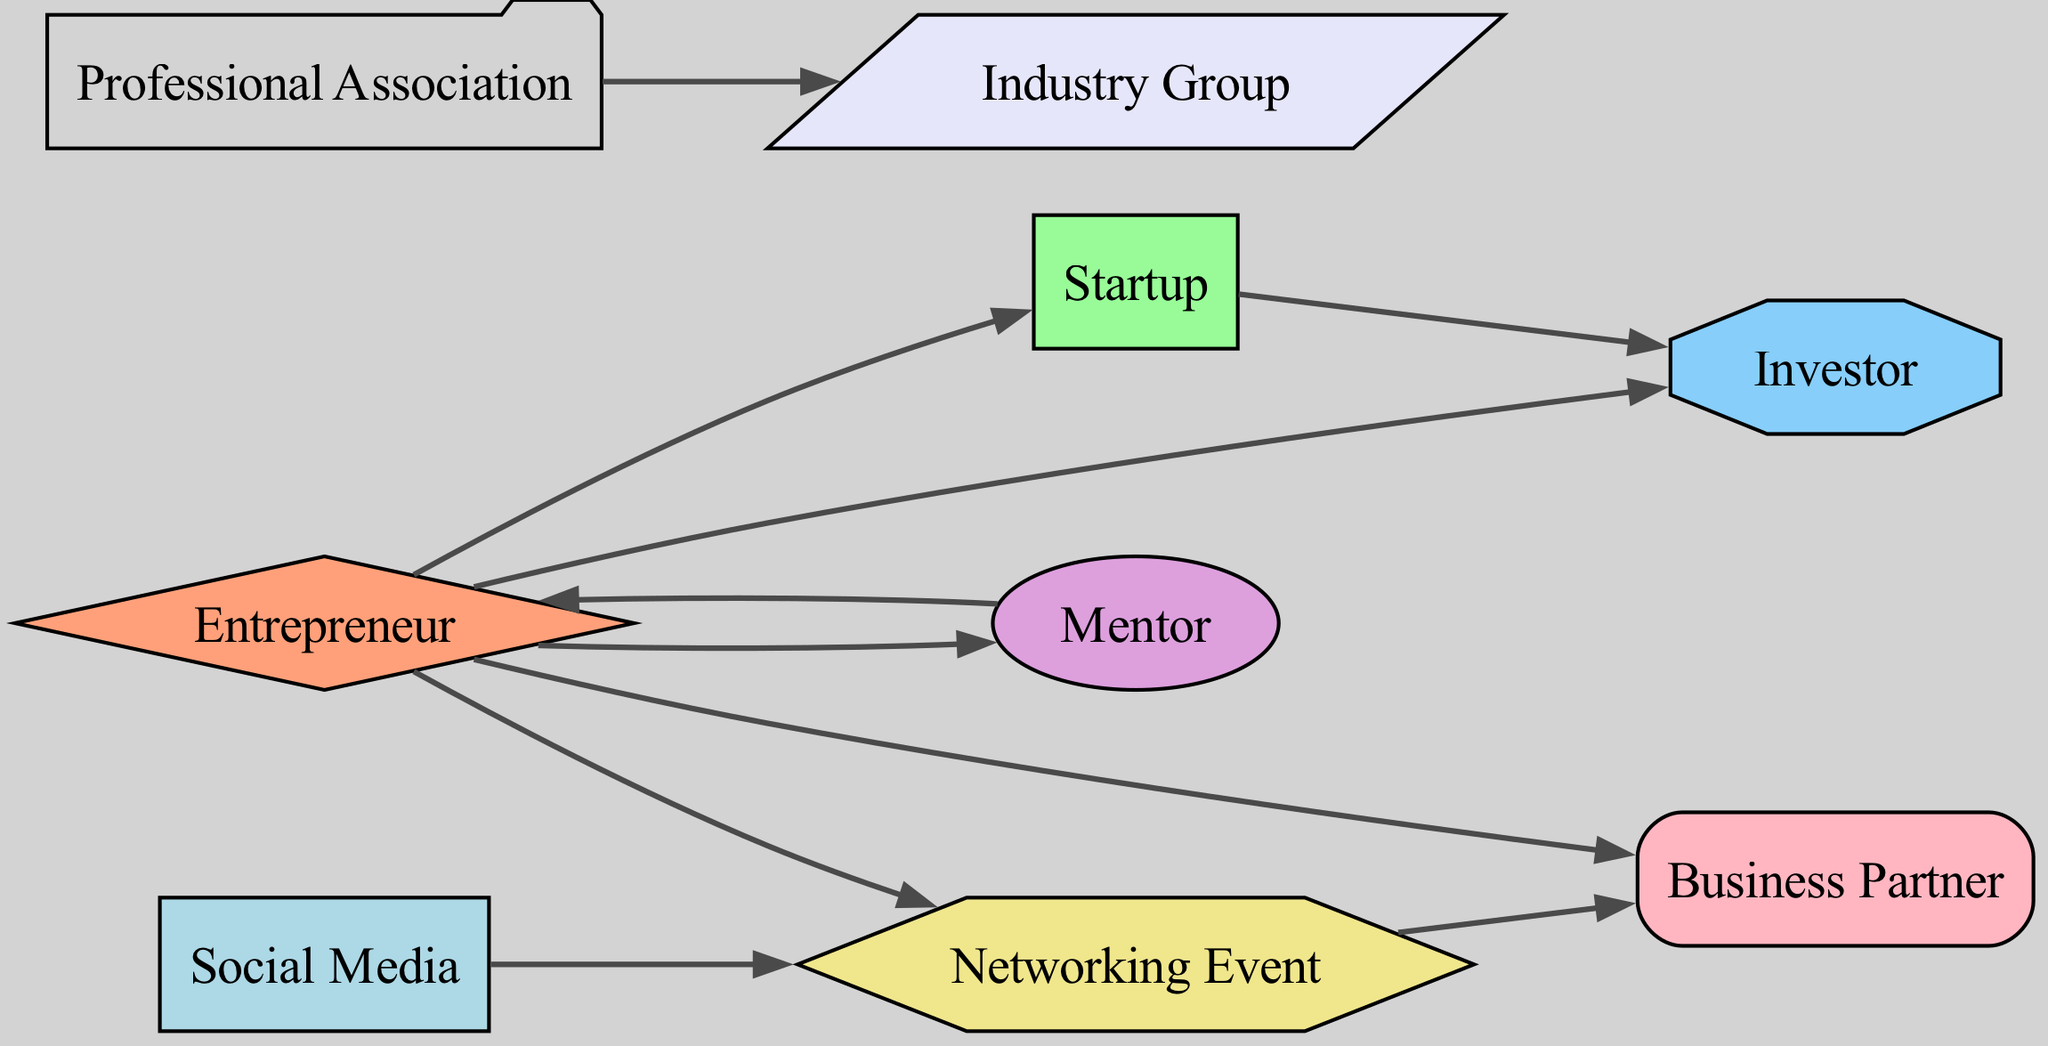What is the starting point in the diagram? The starting point is indicated by the node labeled "Entrepreneur," as it connects to multiple other nodes and initiates the relationships in the diagram.
Answer: Entrepreneur How many nodes are present in the diagram? By counting the nodes listed in the data, we find there are a total of 9 distinct nodes representing different entities in the business networking context.
Answer: 9 Which node connects directly to both "Startup" and "Investor"? The node labeled "Entrepreneur" has directed edges leading to both the "Startup" and "Investor" nodes, indicating its direct involvement with both entities in the networking process.
Answer: Entrepreneur What type of relationship does "Mentor" have with "Entrepreneur"? The relationship between "Mentor" and "Entrepreneur" is a directed one, where "Mentor" directly connects to "Entrepreneur," meaning that the mentor guides or supports the entrepreneur.
Answer: Guidance How many edges are connected to the "Networking Event"? By examining the connections, "Networking Event" has 3 outgoing edges that connect it to "Business Partner," "Social Media," and it is connected to "Entrepreneur" as well.
Answer: 3 Which two nodes have a double connection where one influences the other? The nodes "Entrepreneur" and "Investor" have a double connection; "Entrepreneur" connects to "Investor," and "Startup" also connects to "Investor," showing an influence relationship.
Answer: Entrepreneur, Investor What is the relationship between "Professional Association" and "Industry Group"? The relationship is direct, with "Professional Association" connecting to "Industry Group," indicating that membership or participation in the professional association may lead to engagement with the industry group.
Answer: Membership How does "Social Media" influence the networking process? "Social Media" has a direct edge leading to "Networking Event," showing its role in facilitating or promoting networking opportunities among the connected nodes.
Answer: Facilitation Which node is primarily focused on partnerships? The node labeled "Business Partner" is specifically designated for collaborations or partnerships, as identified by the directed edge relationships surrounding it in the diagram.
Answer: Business Partner 